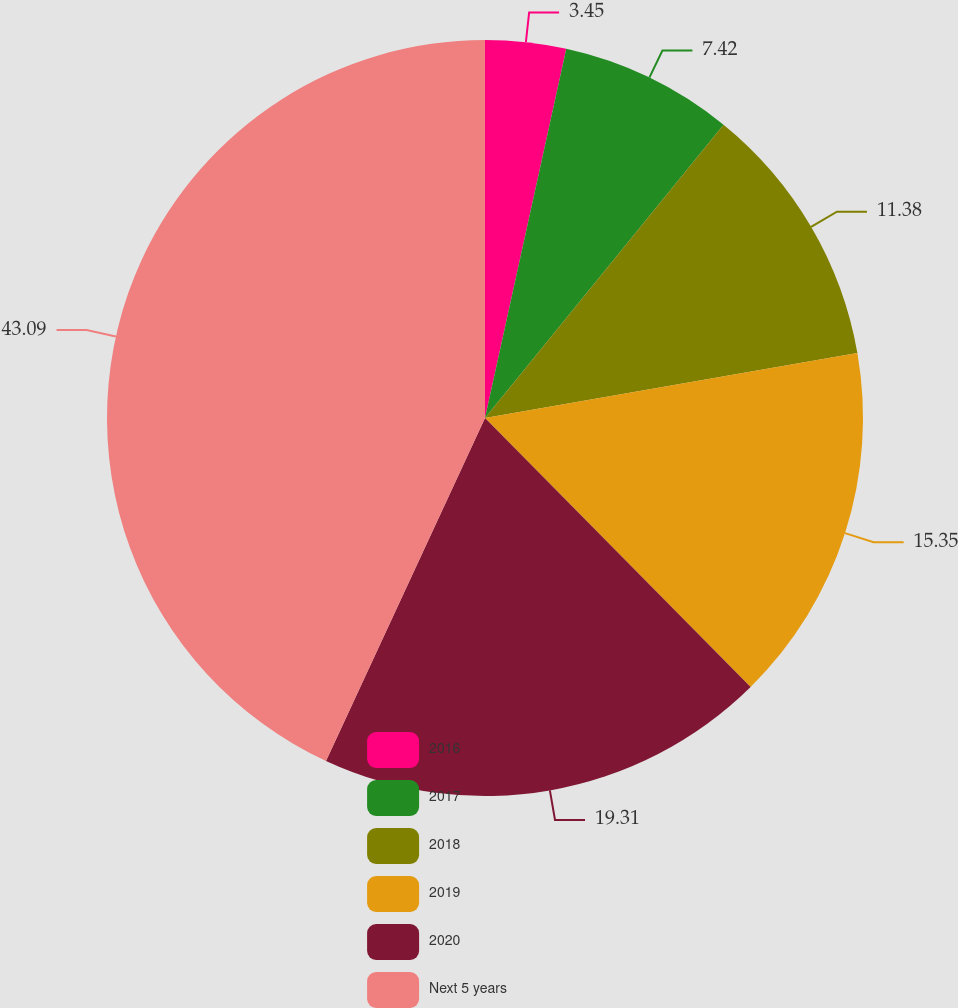Convert chart to OTSL. <chart><loc_0><loc_0><loc_500><loc_500><pie_chart><fcel>2016<fcel>2017<fcel>2018<fcel>2019<fcel>2020<fcel>Next 5 years<nl><fcel>3.45%<fcel>7.42%<fcel>11.38%<fcel>15.35%<fcel>19.31%<fcel>43.09%<nl></chart> 